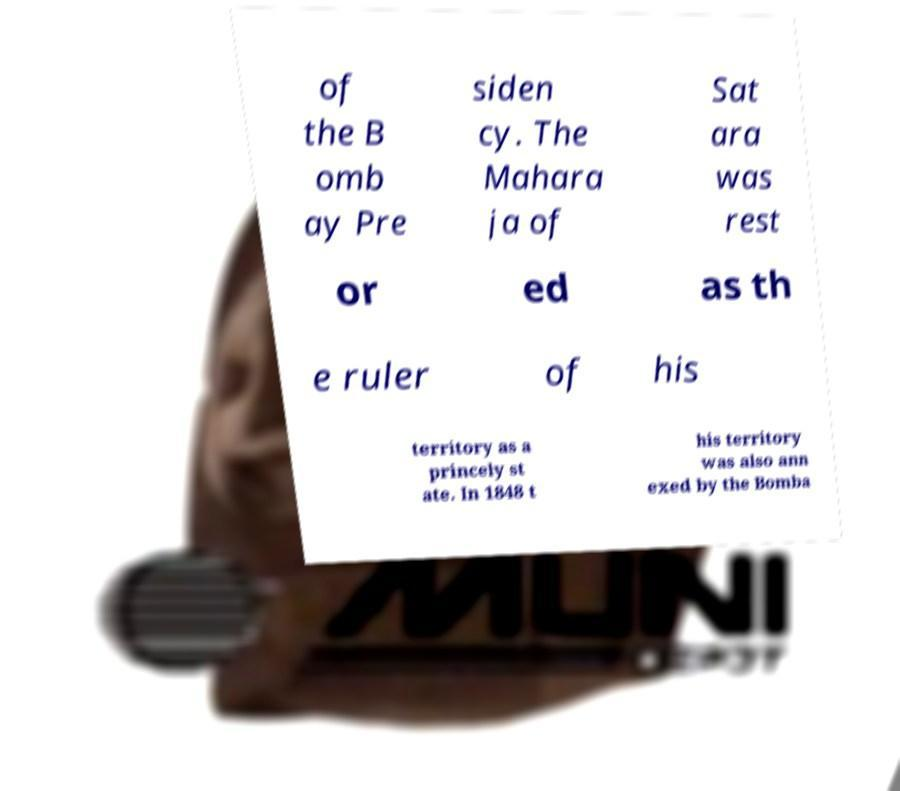I need the written content from this picture converted into text. Can you do that? of the B omb ay Pre siden cy. The Mahara ja of Sat ara was rest or ed as th e ruler of his territory as a princely st ate. In 1848 t his territory was also ann exed by the Bomba 